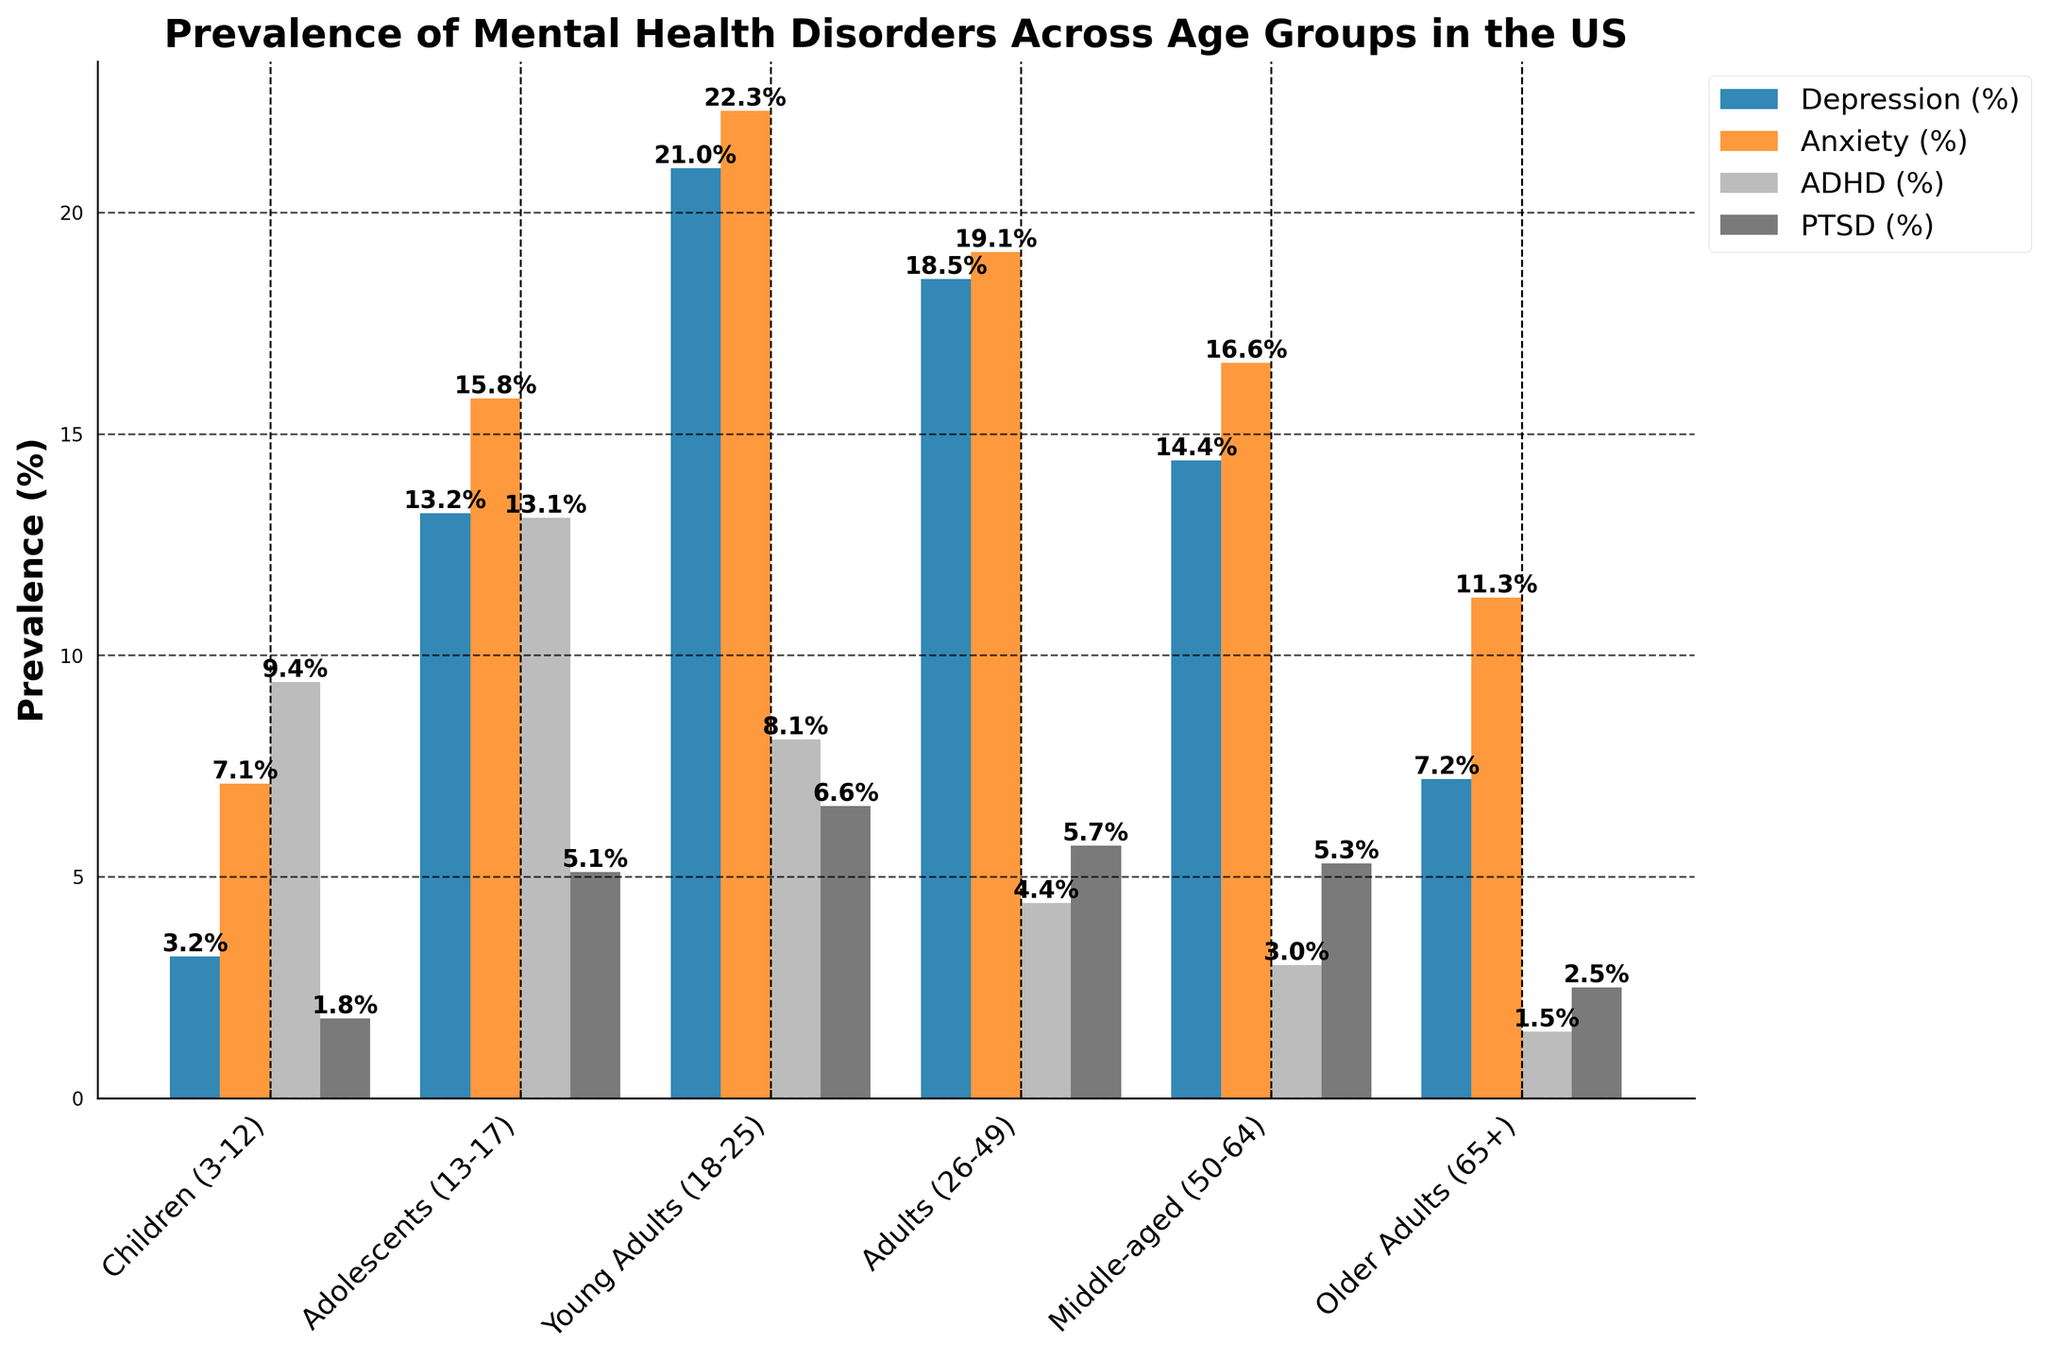What age group has the highest prevalence of depression? The figure shows that the "Young Adults (18-25)" bar for depression is the highest among all age groups.
Answer: Young Adults (18-25) Compare the prevalence of ADHD in Children (3-12) and Adolescents (13-17). Which group has a higher rate? The bar for ADHD in Adolescents (13-17) is taller than the bar for Children (3-12).
Answer: Adolescents (13-17) What is the total prevalence of anxiety across all age groups? Summing the values for anxiety across all age groups: 7.1 (Children) + 15.8 (Adolescents) + 22.3 (Young Adults) + 19.1 (Adults) + 16.6 (Middle-aged) + 11.3 (Older Adults) = 92.2.
Answer: 92.2% How does the prevalence of PTSD in Middle-aged (50-64) individuals compare to that in Adolescents (13-17)? The figure shows that the bar for PTSD in Middle-aged (50-64) is slightly higher than in Adolescents (13-17).
Answer: Middle-aged (50-64) What is the average prevalence of Depression across the first three age groups? The first three age groups are Children (3-12), Adolescents (13-17), and Young Adults (18-25). Their depression rates are 3.2, 13.2, and 21.0 respectively. Average = (3.2 + 13.2 + 21.0) / 3 ≈ 12.47.
Answer: 12.47% Which mental health disorder has the least prevalence in Older Adults (65+)? According to the figure, ADHD has the shortest bar for Older Adults (65+), indicating it has the lowest prevalence.
Answer: ADHD Is there a trend in PTSD prevalence visible across the age groups? The trend in the figure shows that PTSD prevalence generally increases with age until Young Adults (6.6%), then slightly decreases and stays relatively stable among older groups.
Answer: Increasing then stable Which age group has the most balanced prevalence across all four mental health disorders? The figure shows that the bars for each disorder in the Adolescents (13-17) age group are relatively closer in height compared to other groups.
Answer: Adolescents (13-17) What is the difference in anxiety prevalence between Middle-aged (50-64) and Young Adults (18-25)? The anxiety prevalence is 16.6% for Middle-aged and 22.3% for Young Adults. Difference = 22.3 - 16.6 = 5.7.
Answer: 5.7% How does the visual representation of ADHD prevalence in Young Adults (18-25) compare to Children (3-12)? The bar for ADHD in Young Adults (18-25) is shorter than the bar for Children (3-12), indicating a lower prevalence.
Answer: Shorter 